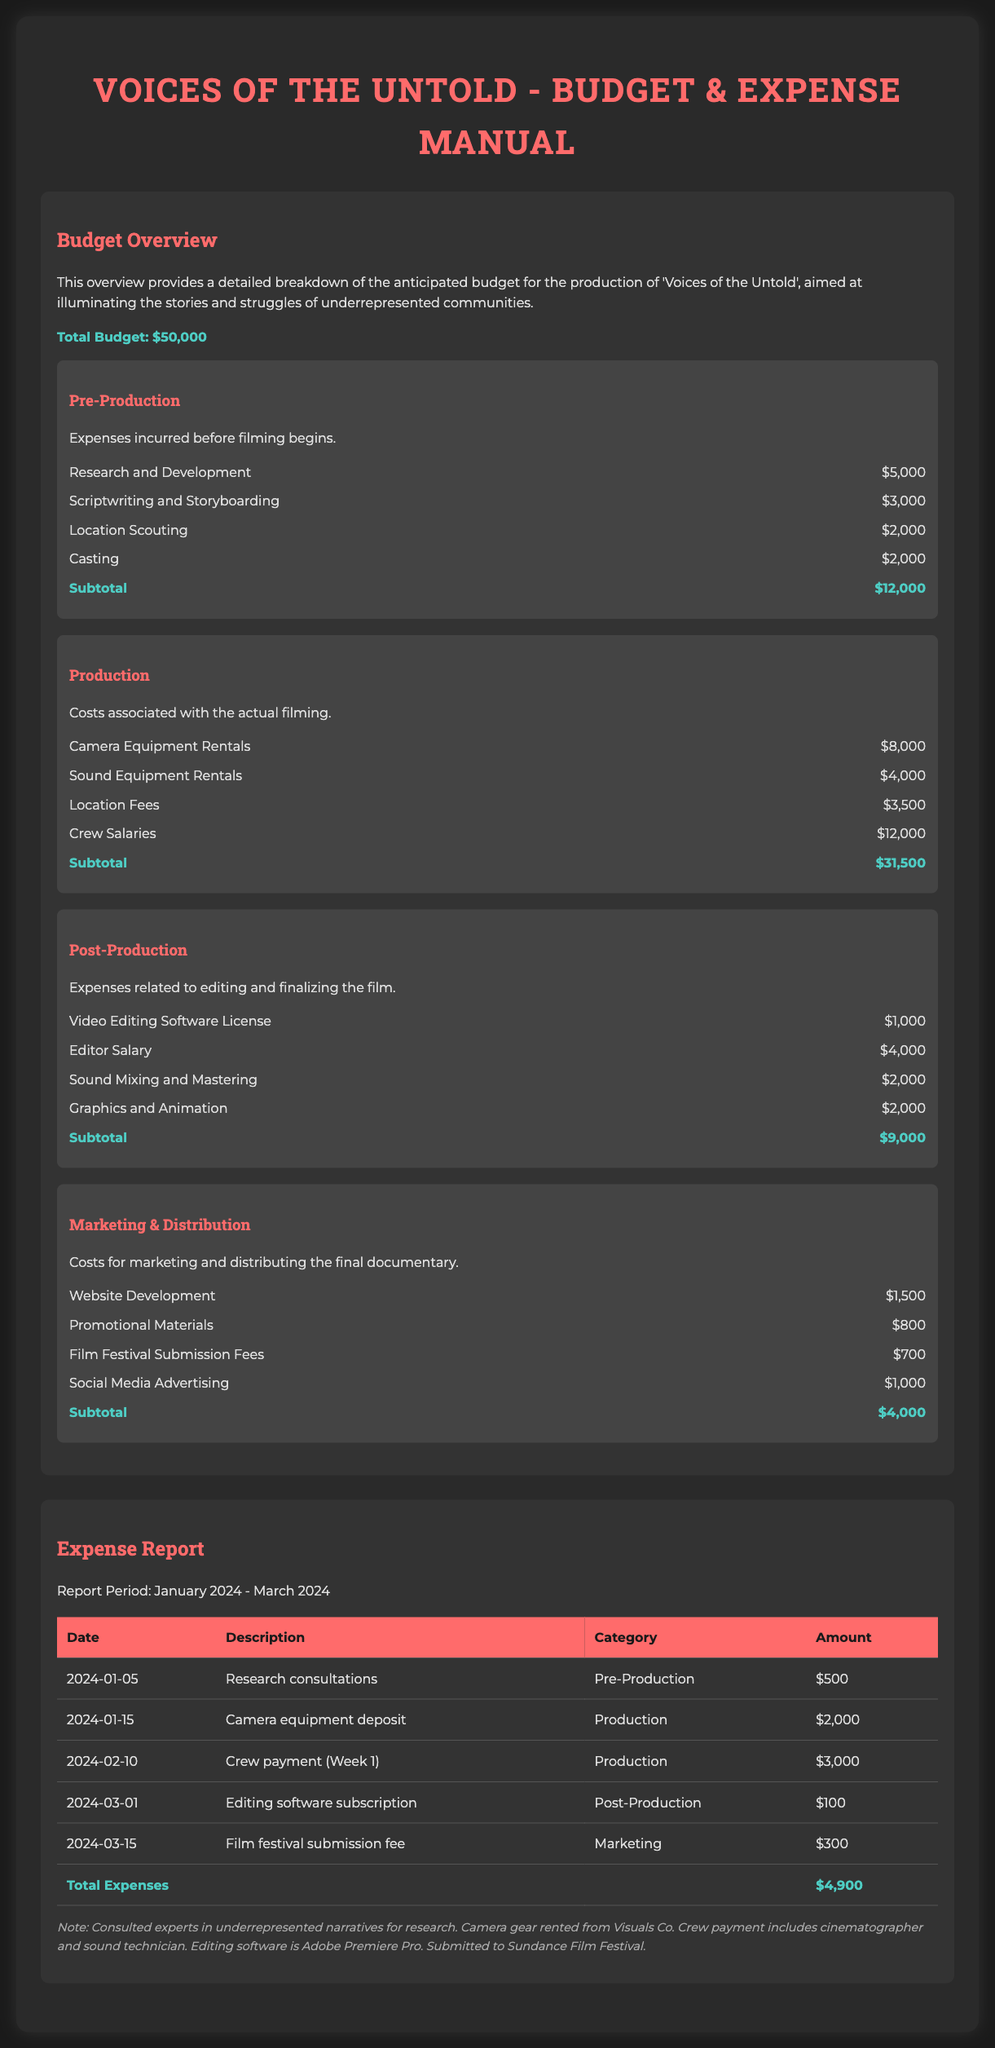what is the total budget? The total budget for the documentary 'Voices of the Untold' is stated directly in the document.
Answer: $50,000 how much was allocated for Crew Salaries? The budget overview provides specific amounts allocated for various categories. Crew Salaries are listed under Production expenses.
Answer: $12,000 what is the subtotal for Marketing & Distribution? The document lists the expenses under the Marketing & Distribution category, which includes specific amounts.
Answer: $4,000 which software license cost $1,000? The budget overview mentions specific costs for various tools and resources in the Post-Production category.
Answer: Video Editing Software License what was the date of the Camera equipment deposit? The expense report lists specific dates for incurred expenses, including the deposit for camera equipment.
Answer: 2024-01-15 how much did the film festival submission fee cost? This fee is specifically itemized in the Expense Report under Marketing and provides a clear amount.
Answer: $300 in which month did the editing software subscription expense occur? The expense report categorizes each expense item along with the corresponding dates, allowing for month identification.
Answer: March how much total was spent by March 2024? The total expenses in the expense report sum up all listed amounts by the end of the reporting period.
Answer: $4,900 which category does 'Research consultations' fall under? The expense report details each incurred expense with their respective categories for clarity.
Answer: Pre-Production 